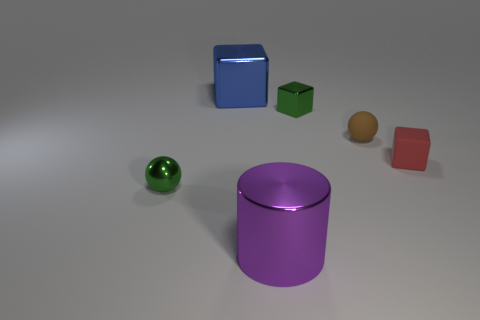Subtract all blue blocks. How many blocks are left? 2 Subtract all cylinders. How many objects are left? 5 Add 2 big purple rubber things. How many objects exist? 8 Subtract all green cubes. How many cubes are left? 2 Subtract 0 purple balls. How many objects are left? 6 Subtract 3 cubes. How many cubes are left? 0 Subtract all gray balls. Subtract all purple cylinders. How many balls are left? 2 Subtract all green cylinders. How many green spheres are left? 1 Subtract all blue cubes. Subtract all tiny red blocks. How many objects are left? 4 Add 5 green metallic spheres. How many green metallic spheres are left? 6 